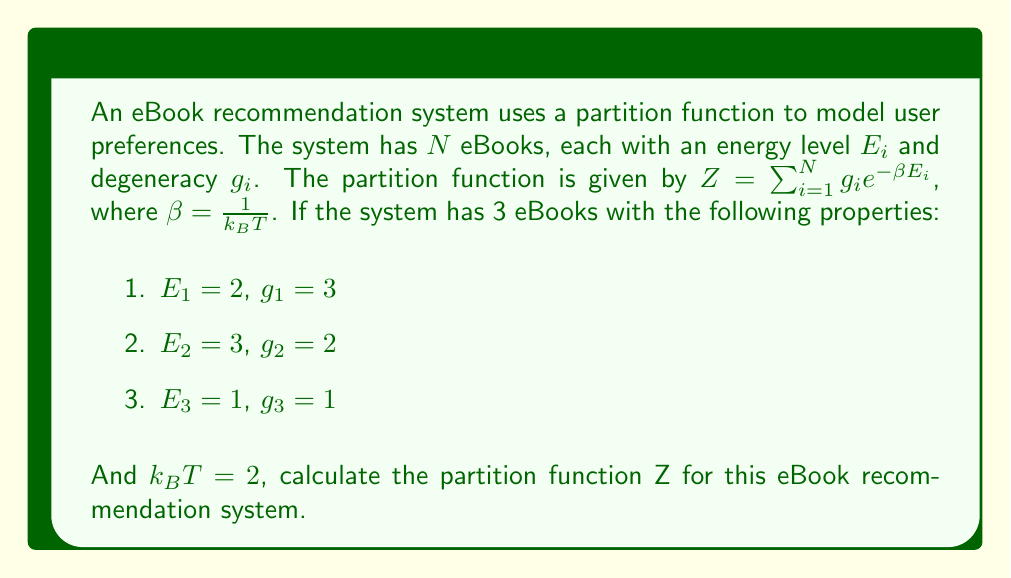What is the answer to this math problem? Let's approach this step-by-step:

1) We are given the partition function formula:
   $$Z = \sum_{i=1}^N g_i e^{-\beta E_i}$$

2) We know that $\beta = \frac{1}{k_B T}$, and $k_B T = 2$, so:
   $$\beta = \frac{1}{2}$$

3) Now, let's calculate the contribution of each eBook to the partition function:

   For eBook 1: $E_1 = 2$, $g_1 = 3$
   $$Z_1 = 3 e^{-\frac{1}{2} \cdot 2} = 3 e^{-1} = \frac{3}{e}$$

   For eBook 2: $E_2 = 3$, $g_2 = 2$
   $$Z_2 = 2 e^{-\frac{1}{2} \cdot 3} = 2 e^{-\frac{3}{2}} = \frac{2}{e^{\frac{3}{2}}}$$

   For eBook 3: $E_3 = 1$, $g_3 = 1$
   $$Z_3 = 1 e^{-\frac{1}{2} \cdot 1} = e^{-\frac{1}{2}} = \frac{1}{\sqrt{e}}$$

4) The total partition function is the sum of these individual contributions:
   $$Z = Z_1 + Z_2 + Z_3 = \frac{3}{e} + \frac{2}{e^{\frac{3}{2}}} + \frac{1}{\sqrt{e}}$$

5) To simplify, let's use a common denominator of $e^{\frac{3}{2}}$:
   $$Z = \frac{3\sqrt{e}}{e^{\frac{3}{2}}} + \frac{2}{e^{\frac{3}{2}}} + \frac{e}{e^{\frac{3}{2}}}$$

6) Combining terms:
   $$Z = \frac{3\sqrt{e} + 2 + e}{e^{\frac{3}{2}}}$$
Answer: $$Z = \frac{3\sqrt{e} + 2 + e}{e^{\frac{3}{2}}}$$ 